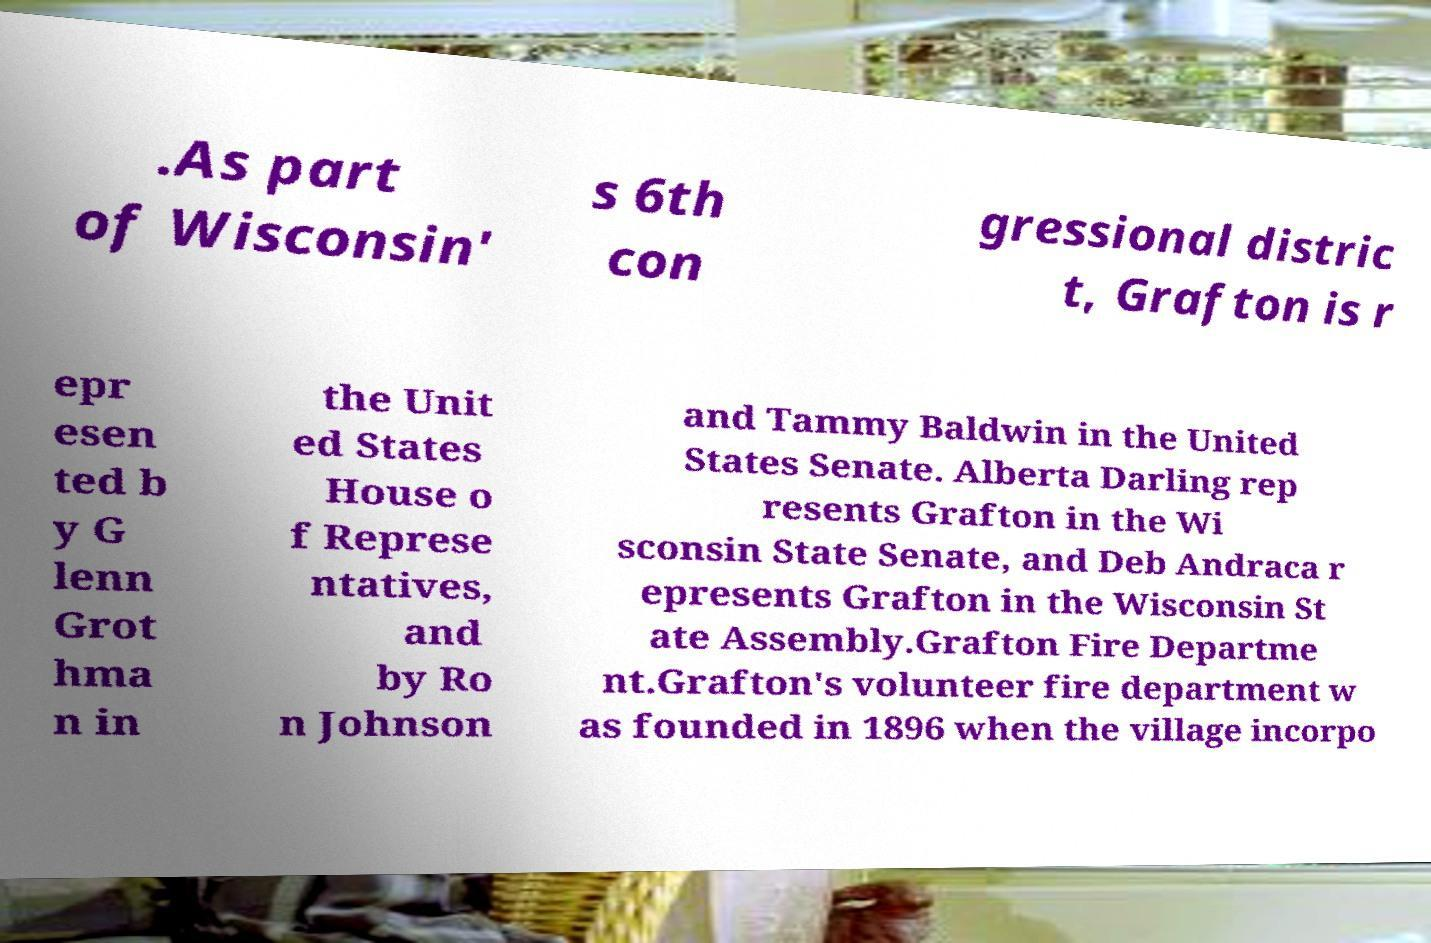There's text embedded in this image that I need extracted. Can you transcribe it verbatim? .As part of Wisconsin' s 6th con gressional distric t, Grafton is r epr esen ted b y G lenn Grot hma n in the Unit ed States House o f Represe ntatives, and by Ro n Johnson and Tammy Baldwin in the United States Senate. Alberta Darling rep resents Grafton in the Wi sconsin State Senate, and Deb Andraca r epresents Grafton in the Wisconsin St ate Assembly.Grafton Fire Departme nt.Grafton's volunteer fire department w as founded in 1896 when the village incorpo 